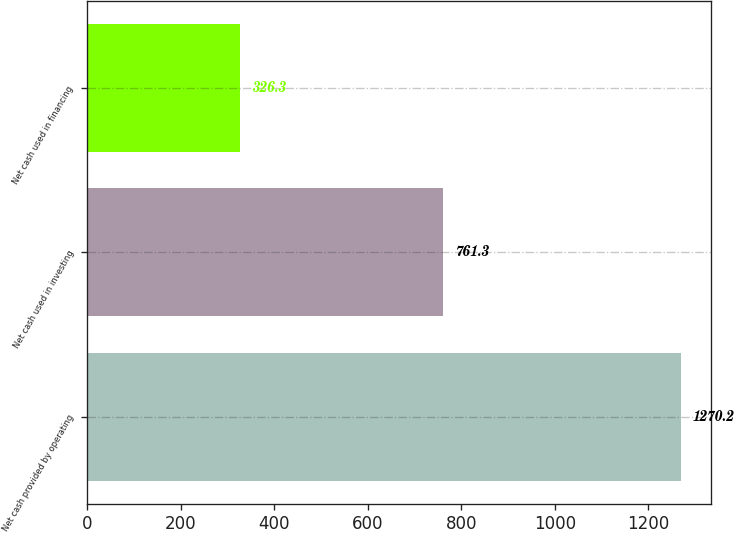Convert chart to OTSL. <chart><loc_0><loc_0><loc_500><loc_500><bar_chart><fcel>Net cash provided by operating<fcel>Net cash used in investing<fcel>Net cash used in financing<nl><fcel>1270.2<fcel>761.3<fcel>326.3<nl></chart> 